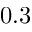<formula> <loc_0><loc_0><loc_500><loc_500>0 . 3</formula> 